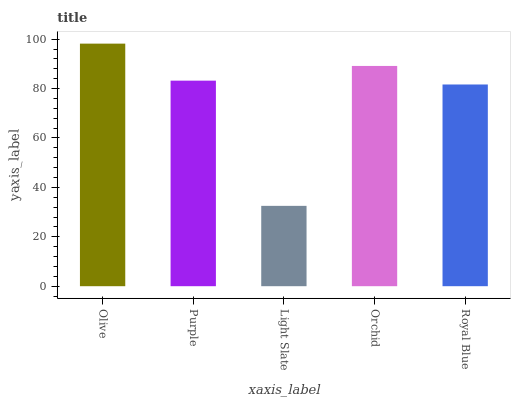Is Purple the minimum?
Answer yes or no. No. Is Purple the maximum?
Answer yes or no. No. Is Olive greater than Purple?
Answer yes or no. Yes. Is Purple less than Olive?
Answer yes or no. Yes. Is Purple greater than Olive?
Answer yes or no. No. Is Olive less than Purple?
Answer yes or no. No. Is Purple the high median?
Answer yes or no. Yes. Is Purple the low median?
Answer yes or no. Yes. Is Light Slate the high median?
Answer yes or no. No. Is Olive the low median?
Answer yes or no. No. 